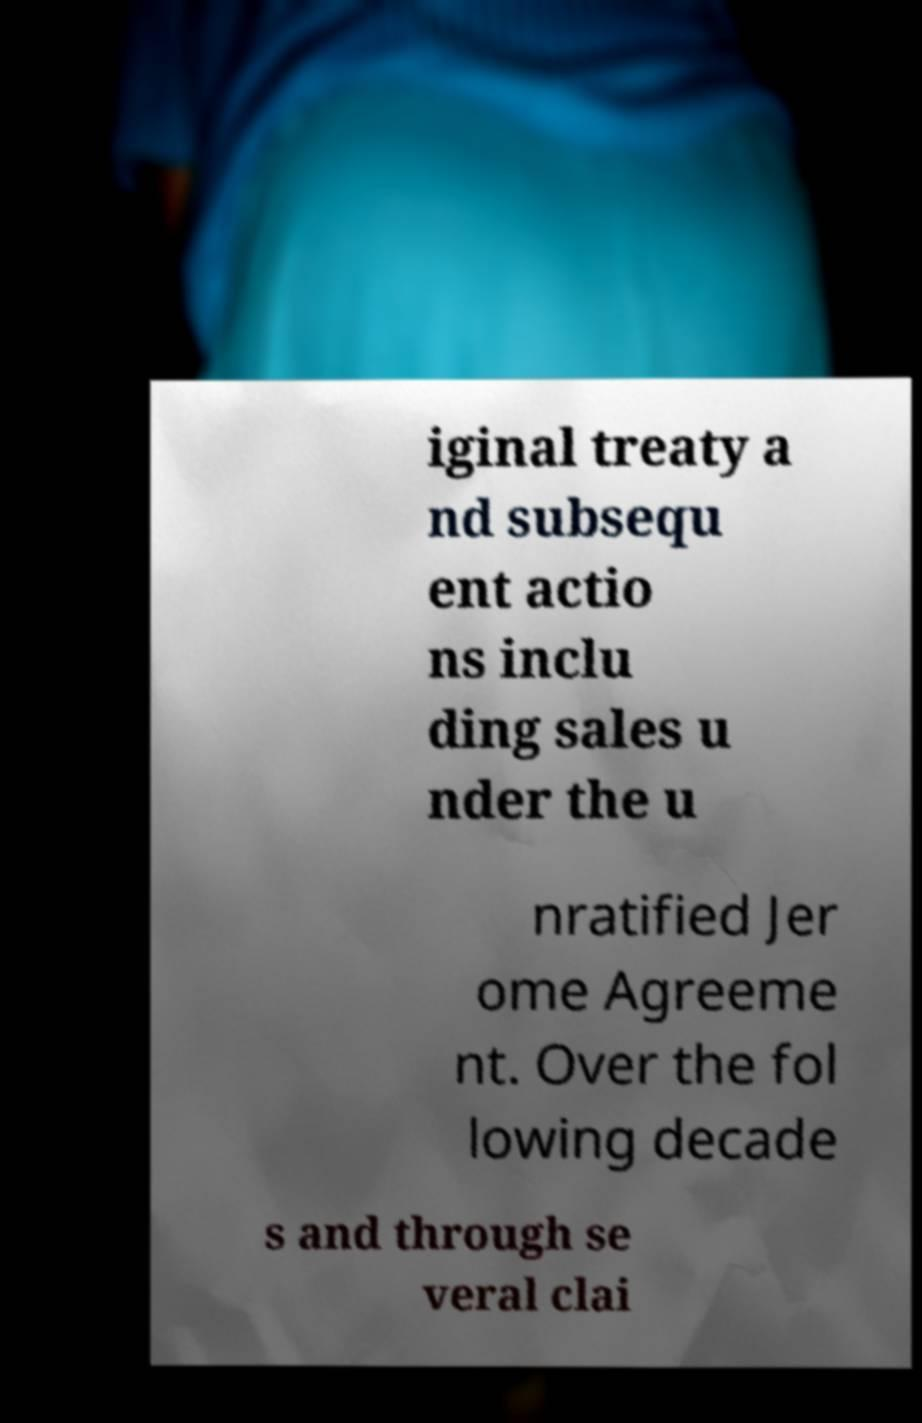I need the written content from this picture converted into text. Can you do that? iginal treaty a nd subsequ ent actio ns inclu ding sales u nder the u nratified Jer ome Agreeme nt. Over the fol lowing decade s and through se veral clai 